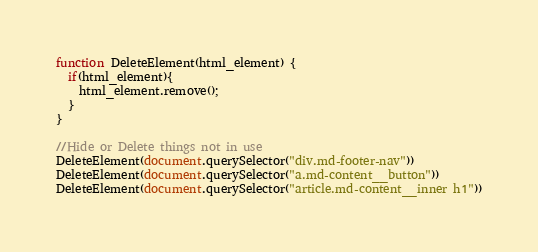<code> <loc_0><loc_0><loc_500><loc_500><_JavaScript_>function DeleteElement(html_element) {
  if(html_element){
    html_element.remove();
  }
} 

//Hide or Delete things not in use
DeleteElement(document.querySelector("div.md-footer-nav"))
DeleteElement(document.querySelector("a.md-content__button"))
DeleteElement(document.querySelector("article.md-content__inner h1"))

</code> 